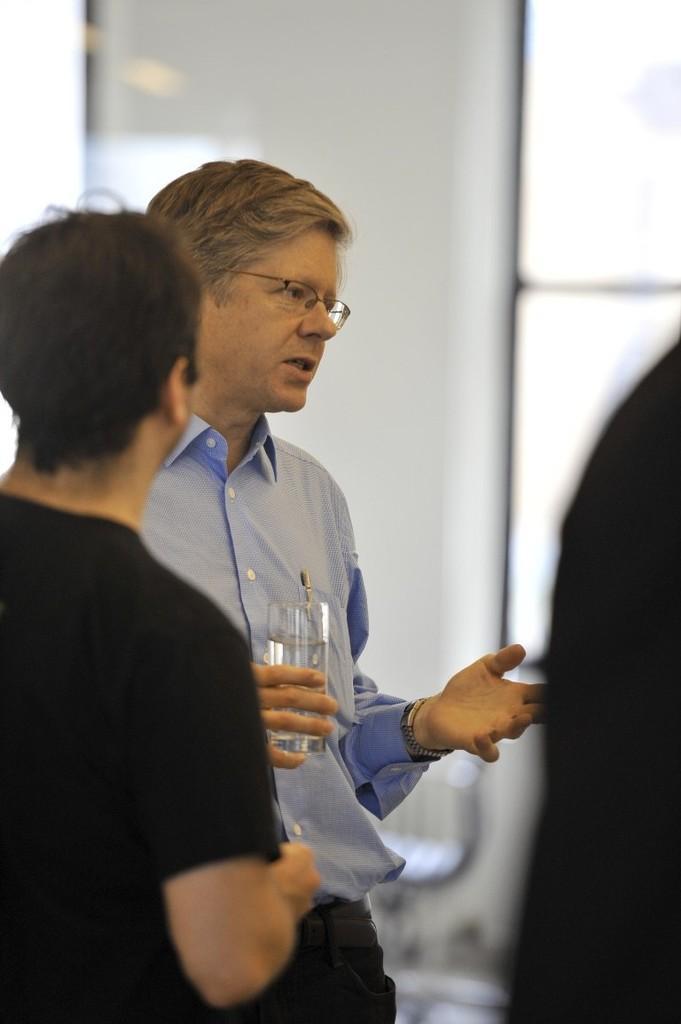How would you summarize this image in a sentence or two? In this picture we can see few people, in the middle of the image we can find a man, he wore spectacles and he is holding a glass. 